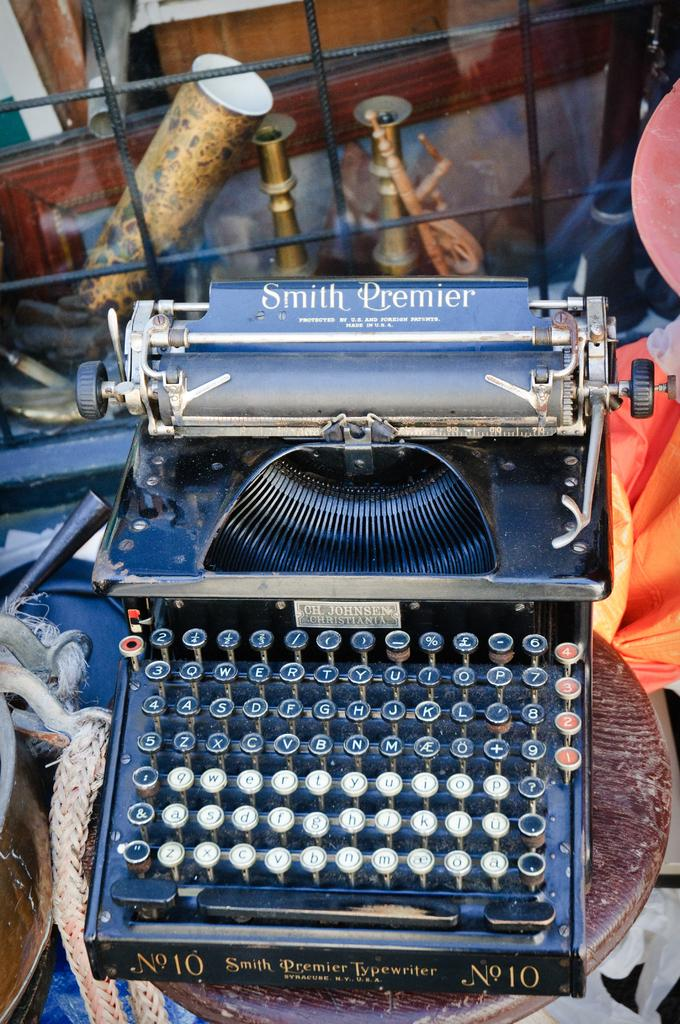<image>
Create a compact narrative representing the image presented. An antique Smith Premier typewriter with blue keys. 